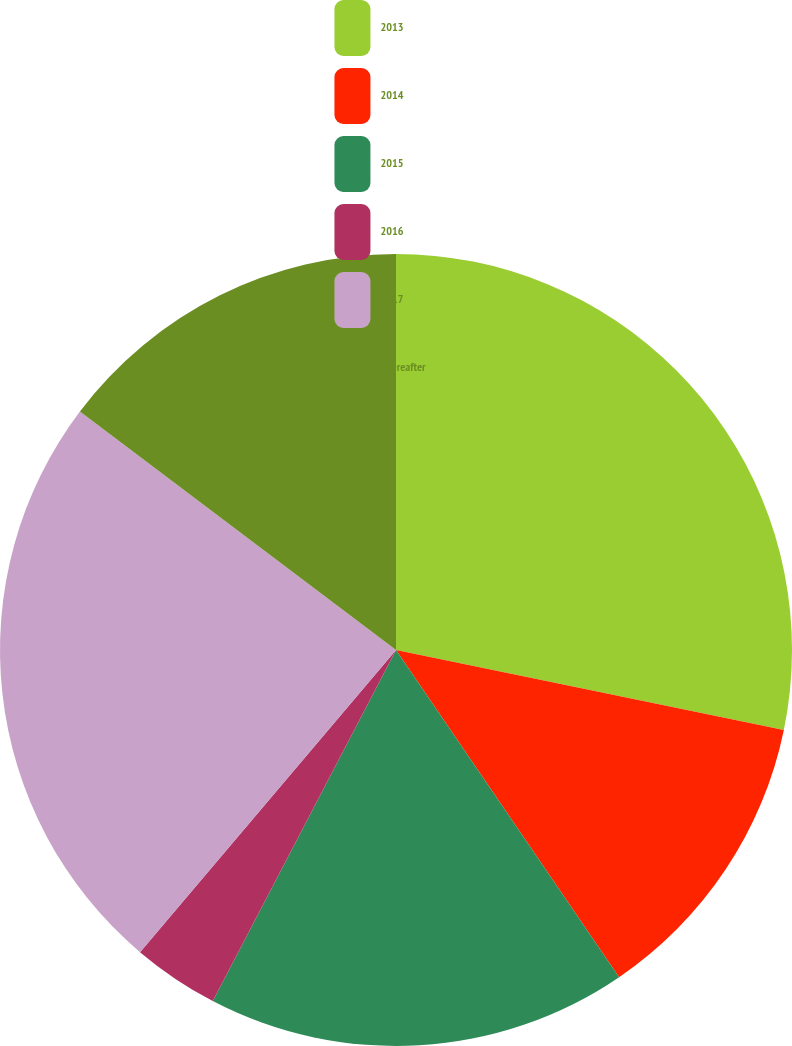Convert chart to OTSL. <chart><loc_0><loc_0><loc_500><loc_500><pie_chart><fcel>2013<fcel>2014<fcel>2015<fcel>2016<fcel>2017<fcel>Thereafter<nl><fcel>28.23%<fcel>12.24%<fcel>17.18%<fcel>3.53%<fcel>24.1%<fcel>14.71%<nl></chart> 